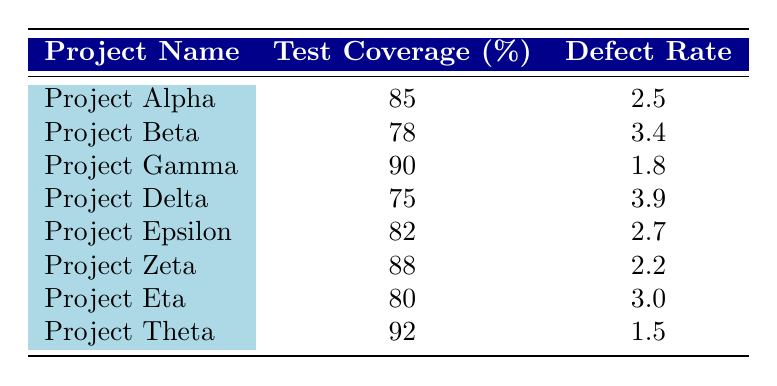What is the defect rate for Project Gamma? The defect rate is directly provided in the table under the defect rate column for Project Gamma, which states 1.8.
Answer: 1.8 What is the test coverage percentage for Project Zeta? The test coverage percentage is directly provided in the table under the test coverage column for Project Zeta, which states 88.
Answer: 88 Which project has the highest test coverage percentage? By reviewing the test coverage percentages in the table, Project Theta has the highest at 92.
Answer: Project Theta What is the average defect rate across all projects? To find the average defect rate, sum the defect rates: (2.5 + 3.4 + 1.8 + 3.9 + 2.7 + 2.2 + 3.0 + 1.5) = 21.0. There are 8 projects, so the average is 21.0 / 8 = 2.625.
Answer: 2.625 Is there a project with test coverage of 75% or lower that has a defect rate higher than 3? Project Delta has a test coverage of 75% and a defect rate of 3.9, which meets the criteria.
Answer: Yes What is the difference in defect rate between Project Alpha and Project Epsilon? The defect rate for Project Alpha is 2.5 and for Project Epsilon is 2.7. The difference is 2.7 - 2.5 = 0.2.
Answer: 0.2 Which projects have a defect rate below 2.5? Inspecting the table, the defect rates below 2.5 are found in Project Gamma (1.8), and Project Theta (1.5).
Answer: Project Gamma, Project Theta Are there any projects with a defect rate above 3.5? Checking the defect rates, Project Beta (3.4), Project Delta (3.9), and Project Eta (3.0) have rates, but only Project Delta exceeds 3.5.
Answer: Yes How does the defect rate for Project Zeta compare to Project Alpha? The defect rate for Project Zeta is 2.2, while for Project Alpha it is 2.5. This indicates Project Zeta has a lower defect rate than Project Alpha by 2.5 - 2.2 = 0.3.
Answer: 0.3 lower 